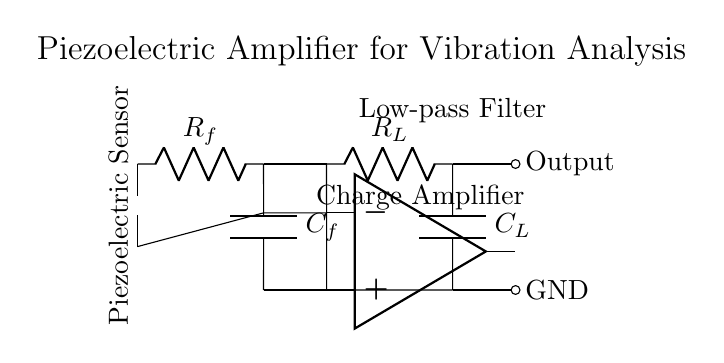What type of sensor is used in this circuit? The diagram clearly shows a piezoelectric sensor at the leftmost part, which is indicated by the component labeled as "Piezoelectric Sensor."
Answer: Piezoelectric sensor What is the function of the operational amplifier in this circuit? The operational amplifier is designed as a charge amplifier to increase the signal from the piezoelectric sensor, as denoted by the label "Charge Amplifier" above the op amp symbol.
Answer: Charge amplifier Which components are part of the low-pass filter? The low-pass filter consists of a resistor R_L and a capacitor C_L, which are labeled clearly in the diagram under the section titled "Low-pass Filter."
Answer: Resistor and capacitor What happens to the signal after the charge amplifier? After the charge amplifier, the signal goes through a low-pass filter, which indicates that it is further processed to remove high-frequency noise before reaching the output.
Answer: Low-pass filter How many main sections are there in this circuit? The diagram depicts three main sections: the piezoelectric sensor, the charge amplifier, and the low-pass filter, clearly indicated by their respective labels.
Answer: Three What is the purpose of the capacitor labeled C_f? The capacitor C_f serves to couple the output of the charge amplifier and filter the AC component, which helps to stabilize the output voltage by allowing only certain frequencies to pass.
Answer: To couple and filter AC What is indicated at the output node of the circuit? The output node is marked by the symbol for output and is connected to the low-pass filter, which suggests that it presents the final processed signal from the piezoelectric sensor.
Answer: Final processed signal 